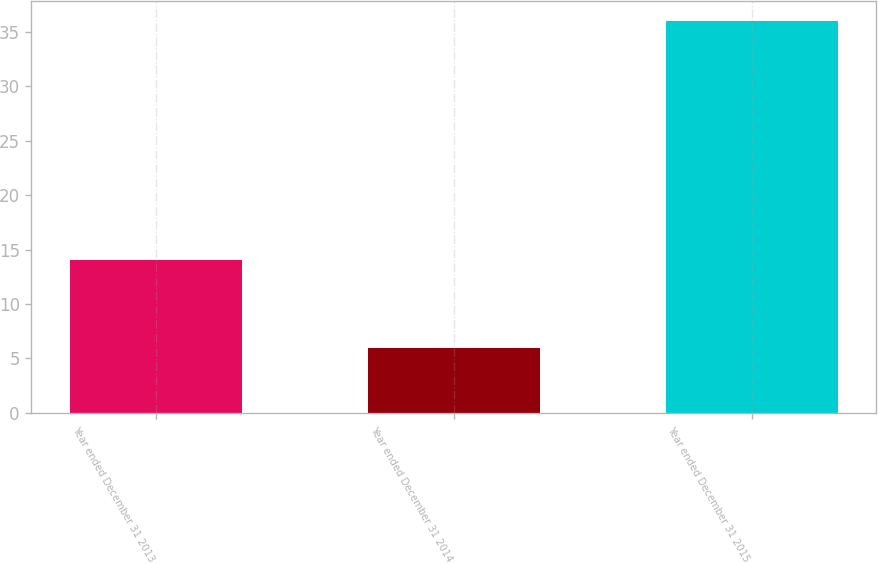<chart> <loc_0><loc_0><loc_500><loc_500><bar_chart><fcel>Year ended December 31 2013<fcel>Year ended December 31 2014<fcel>Year ended December 31 2015<nl><fcel>14<fcel>6<fcel>36<nl></chart> 